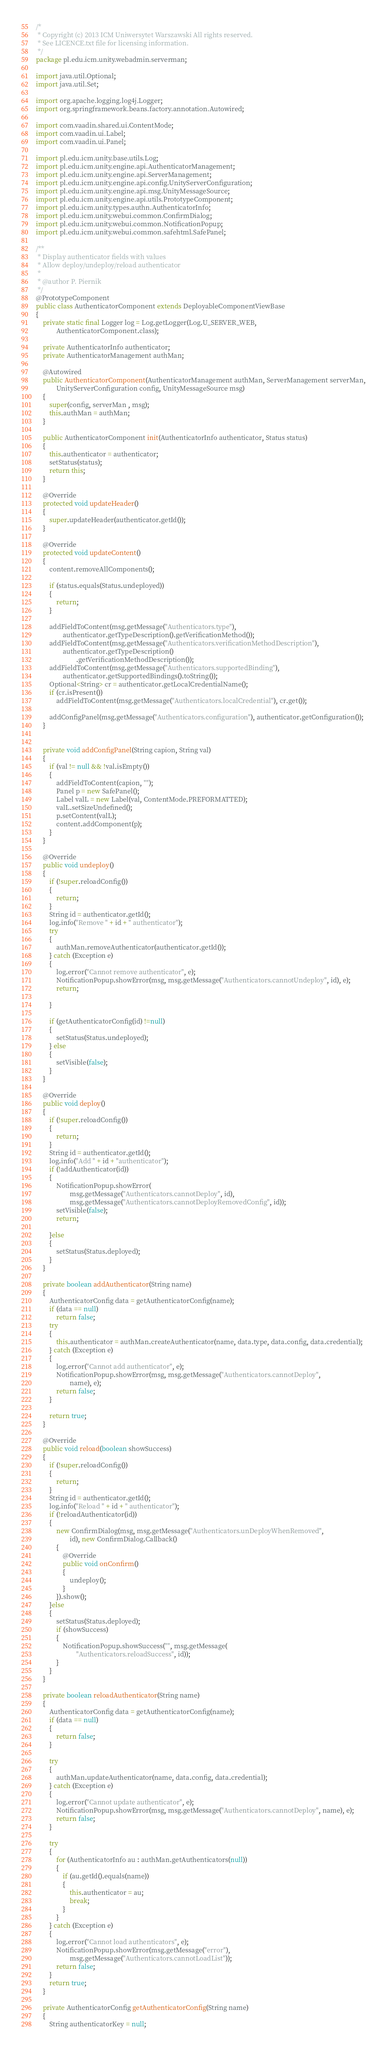Convert code to text. <code><loc_0><loc_0><loc_500><loc_500><_Java_>/*
 * Copyright (c) 2013 ICM Uniwersytet Warszawski All rights reserved.
 * See LICENCE.txt file for licensing information.
 */
package pl.edu.icm.unity.webadmin.serverman;

import java.util.Optional;
import java.util.Set;

import org.apache.logging.log4j.Logger;
import org.springframework.beans.factory.annotation.Autowired;

import com.vaadin.shared.ui.ContentMode;
import com.vaadin.ui.Label;
import com.vaadin.ui.Panel;

import pl.edu.icm.unity.base.utils.Log;
import pl.edu.icm.unity.engine.api.AuthenticatorManagement;
import pl.edu.icm.unity.engine.api.ServerManagement;
import pl.edu.icm.unity.engine.api.config.UnityServerConfiguration;
import pl.edu.icm.unity.engine.api.msg.UnityMessageSource;
import pl.edu.icm.unity.engine.api.utils.PrototypeComponent;
import pl.edu.icm.unity.types.authn.AuthenticatorInfo;
import pl.edu.icm.unity.webui.common.ConfirmDialog;
import pl.edu.icm.unity.webui.common.NotificationPopup;
import pl.edu.icm.unity.webui.common.safehtml.SafePanel;

/**
 * Display authenticator fields with values
 * Allow deploy/undeploy/reload authenticator
 * 
 * @author P. Piernik
 */
@PrototypeComponent
public class AuthenticatorComponent extends DeployableComponentViewBase
{
	private static final Logger log = Log.getLogger(Log.U_SERVER_WEB,
			AuthenticatorComponent.class);

	private AuthenticatorInfo authenticator;
	private AuthenticatorManagement authMan;

	@Autowired
	public AuthenticatorComponent(AuthenticatorManagement authMan, ServerManagement serverMan,
			UnityServerConfiguration config, UnityMessageSource msg)
	{
		super(config, serverMan , msg);
		this.authMan = authMan;
	}

	public AuthenticatorComponent init(AuthenticatorInfo authenticator, Status status)
	{
		this.authenticator = authenticator;
		setStatus(status);
		return this;
	}

	@Override
	protected void updateHeader()
	{
		super.updateHeader(authenticator.getId());
	}

	@Override
	protected void updateContent()
	{
		content.removeAllComponents();
		
		if (status.equals(Status.undeployed))
		{
			return;
		}
		
		addFieldToContent(msg.getMessage("Authenticators.type"), 
				authenticator.getTypeDescription().getVerificationMethod());
		addFieldToContent(msg.getMessage("Authenticators.verificationMethodDescription"),
				authenticator.getTypeDescription()
						.getVerificationMethodDescription());
		addFieldToContent(msg.getMessage("Authenticators.supportedBinding"), 
				authenticator.getSupportedBindings().toString());
		Optional<String> cr = authenticator.getLocalCredentialName();
		if (cr.isPresent())
			addFieldToContent(msg.getMessage("Authenticators.localCredential"), cr.get());
		
		addConfigPanel(msg.getMessage("Authenticators.configuration"), authenticator.getConfiguration());
	}
	
	
	private void addConfigPanel(String capion, String val)
	{
		if (val != null && !val.isEmpty())
		{
			addFieldToContent(capion, "");
			Panel p = new SafePanel();
			Label valL = new Label(val, ContentMode.PREFORMATTED);
			valL.setSizeUndefined();
			p.setContent(valL);
			content.addComponent(p);
		}
	}

	@Override
	public void undeploy()
	{
		if (!super.reloadConfig())
		{
			return;
		}
		String id = authenticator.getId();
		log.info("Remove " + id + " authenticator");
		try
		{
			authMan.removeAuthenticator(authenticator.getId());
		} catch (Exception e)
		{
			log.error("Cannot remove authenticator", e);
			NotificationPopup.showError(msg, msg.getMessage("Authenticators.cannotUndeploy", id), e);
			return;

		}

		if (getAuthenticatorConfig(id) !=null)
		{
			setStatus(Status.undeployed);
		} else
		{
			setVisible(false);
		}
	}

	@Override
	public void deploy()
	{
		if (!super.reloadConfig())
		{
			return;
		}
		String id = authenticator.getId();
		log.info("Add " + id + "authenticator");
		if (!addAuthenticator(id))
		{
			NotificationPopup.showError(
					msg.getMessage("Authenticators.cannotDeploy", id),
					msg.getMessage("Authenticators.cannotDeployRemovedConfig", id));
			setVisible(false);
			return;

		}else
		{
			setStatus(Status.deployed);
		}
	}
	
	private boolean addAuthenticator(String name)
	{	
		AuthenticatorConfig data = getAuthenticatorConfig(name);
		if (data == null)
			return false;
		try
		{
			this.authenticator = authMan.createAuthenticator(name, data.type, data.config, data.credential);
		} catch (Exception e)
		{
			log.error("Cannot add authenticator", e);
			NotificationPopup.showError(msg, msg.getMessage("Authenticators.cannotDeploy",
					name), e);
			return false;
		}
		
		return true;
	}
	
	@Override
	public void reload(boolean showSuccess)
	{
		if (!super.reloadConfig())
		{
			return;
		}
		String id = authenticator.getId();
		log.info("Reload " + id + " authenticator");
		if (!reloadAuthenticator(id))
		{
			new ConfirmDialog(msg, msg.getMessage("Authenticators.unDeployWhenRemoved",
					id), new ConfirmDialog.Callback()
			{
				@Override
				public void onConfirm()
				{
					undeploy();
				}
			}).show();
		}else 
		{
			setStatus(Status.deployed);
			if (showSuccess)
			{
				NotificationPopup.showSuccess("", msg.getMessage(
						"Authenticators.reloadSuccess", id));
			}
		}
	}
	
	private boolean reloadAuthenticator(String name)
	{
		AuthenticatorConfig data = getAuthenticatorConfig(name);
		if (data == null)
		{
			return false;
		}
			
		try
		{
			authMan.updateAuthenticator(name, data.config, data.credential);
		} catch (Exception e)
		{
			log.error("Cannot update authenticator", e);
			NotificationPopup.showError(msg, msg.getMessage("Authenticators.cannotDeploy", name), e);
			return false;
		}

		try
		{
			for (AuthenticatorInfo au : authMan.getAuthenticators(null))
			{
				if (au.getId().equals(name))
				{
					this.authenticator = au;
					break;
				}
			}
		} catch (Exception e)
		{
			log.error("Cannot load authenticators", e);
			NotificationPopup.showError(msg.getMessage("error"),
					msg.getMessage("Authenticators.cannotLoadList"));
			return false;
		}
		return true;
	}
	
	private AuthenticatorConfig getAuthenticatorConfig(String name)
	{
		String authenticatorKey = null;</code> 